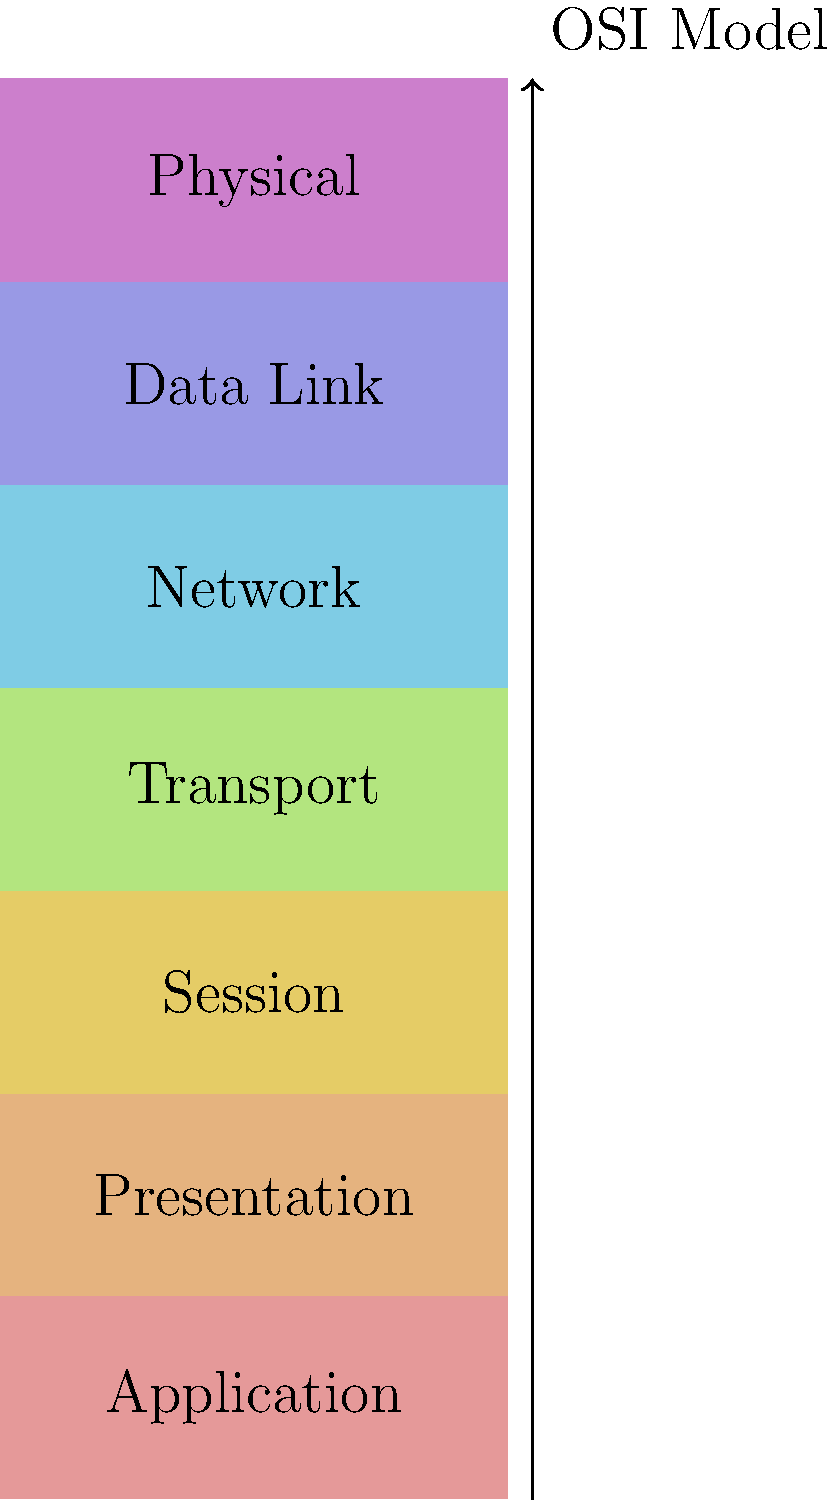In the OSI model, which layer is responsible for routing and addressing data packets between different networks? To answer this question, let's break down the OSI model layers and their functions:

1. Physical Layer: Deals with the physical transmission of data bits over a medium.
2. Data Link Layer: Handles error-free transfer of data between adjacent network nodes.
3. Network Layer: Responsible for routing and addressing data packets between different networks.
4. Transport Layer: Ensures end-to-end communication and data integrity.
5. Session Layer: Manages and terminates connections between applications.
6. Presentation Layer: Formats and encrypts data for the application layer.
7. Application Layer: Provides network services directly to end-users or applications.

The layer responsible for routing and addressing data packets between different networks is the Network Layer (Layer 3). This layer determines the best path for data to travel from source to destination, often across multiple networks. It uses logical addressing (such as IP addresses) to identify devices on different networks and makes decisions on how to route data packets efficiently.

Key functions of the Network Layer include:
- Logical addressing
- Routing
- Path determination
- Packet forwarding
- Fragmentation and reassembly of packets

Therefore, the Network Layer is the correct answer to this question.
Answer: Network Layer 